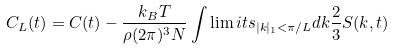Convert formula to latex. <formula><loc_0><loc_0><loc_500><loc_500>C _ { L } ( t ) = C ( t ) - \frac { k _ { B } T } { \rho ( 2 \pi ) ^ { 3 } N } \int \lim i t s _ { | k | _ { 1 } < \pi / L } d k \frac { 2 } { 3 } S ( k , t )</formula> 